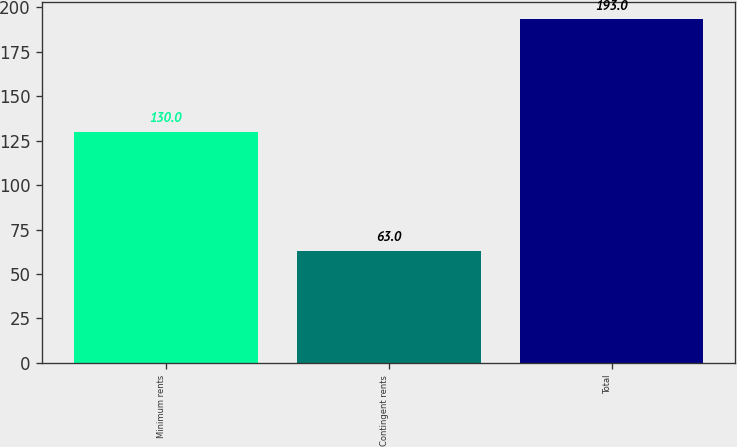Convert chart. <chart><loc_0><loc_0><loc_500><loc_500><bar_chart><fcel>Minimum rents<fcel>Contingent rents<fcel>Total<nl><fcel>130<fcel>63<fcel>193<nl></chart> 